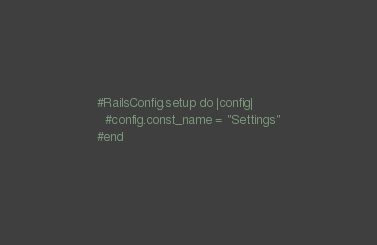Convert code to text. <code><loc_0><loc_0><loc_500><loc_500><_Ruby_>#RailsConfig.setup do |config|
  #config.const_name = "Settings"
#end</code> 